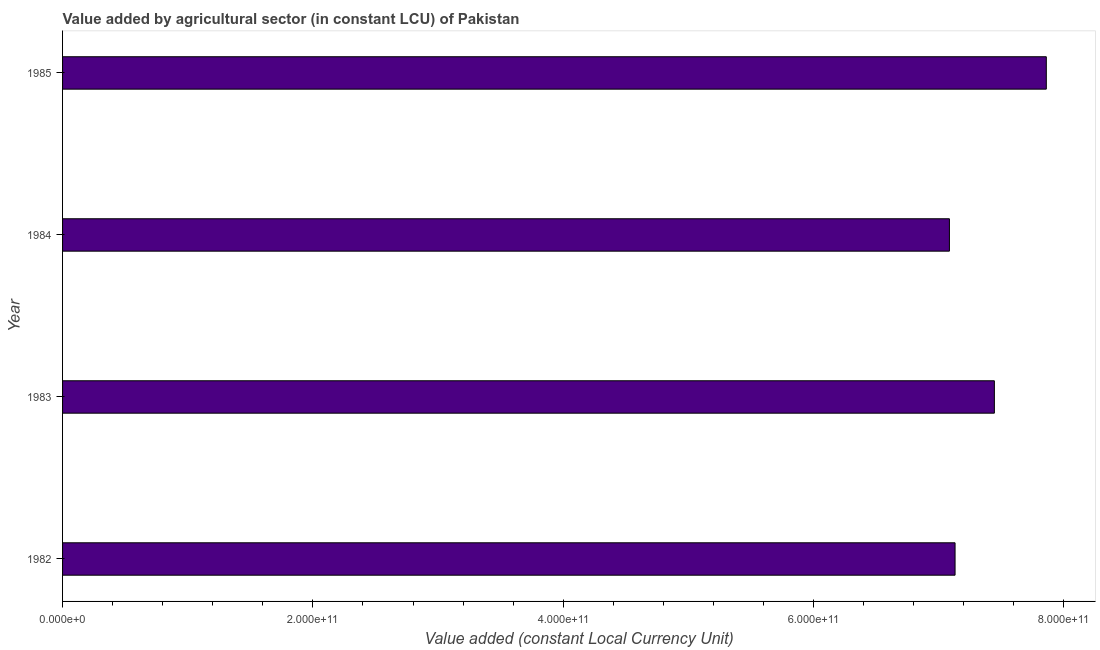Does the graph contain any zero values?
Give a very brief answer. No. What is the title of the graph?
Provide a succinct answer. Value added by agricultural sector (in constant LCU) of Pakistan. What is the label or title of the X-axis?
Your answer should be very brief. Value added (constant Local Currency Unit). What is the label or title of the Y-axis?
Your answer should be compact. Year. What is the value added by agriculture sector in 1985?
Your response must be concise. 7.86e+11. Across all years, what is the maximum value added by agriculture sector?
Provide a succinct answer. 7.86e+11. Across all years, what is the minimum value added by agriculture sector?
Ensure brevity in your answer.  7.09e+11. What is the sum of the value added by agriculture sector?
Provide a succinct answer. 2.95e+12. What is the difference between the value added by agriculture sector in 1983 and 1985?
Offer a terse response. -4.15e+1. What is the average value added by agriculture sector per year?
Ensure brevity in your answer.  7.38e+11. What is the median value added by agriculture sector?
Offer a very short reply. 7.29e+11. In how many years, is the value added by agriculture sector greater than 520000000000 LCU?
Provide a succinct answer. 4. What is the ratio of the value added by agriculture sector in 1983 to that in 1984?
Your answer should be compact. 1.05. Is the difference between the value added by agriculture sector in 1983 and 1985 greater than the difference between any two years?
Your answer should be compact. No. What is the difference between the highest and the second highest value added by agriculture sector?
Your response must be concise. 4.15e+1. Is the sum of the value added by agriculture sector in 1984 and 1985 greater than the maximum value added by agriculture sector across all years?
Provide a short and direct response. Yes. What is the difference between the highest and the lowest value added by agriculture sector?
Your answer should be very brief. 7.74e+1. How many bars are there?
Offer a very short reply. 4. What is the difference between two consecutive major ticks on the X-axis?
Give a very brief answer. 2.00e+11. What is the Value added (constant Local Currency Unit) of 1982?
Your answer should be very brief. 7.13e+11. What is the Value added (constant Local Currency Unit) of 1983?
Your response must be concise. 7.45e+11. What is the Value added (constant Local Currency Unit) of 1984?
Offer a terse response. 7.09e+11. What is the Value added (constant Local Currency Unit) of 1985?
Offer a very short reply. 7.86e+11. What is the difference between the Value added (constant Local Currency Unit) in 1982 and 1983?
Offer a very short reply. -3.14e+1. What is the difference between the Value added (constant Local Currency Unit) in 1982 and 1984?
Your response must be concise. 4.51e+09. What is the difference between the Value added (constant Local Currency Unit) in 1982 and 1985?
Keep it short and to the point. -7.29e+1. What is the difference between the Value added (constant Local Currency Unit) in 1983 and 1984?
Give a very brief answer. 3.59e+1. What is the difference between the Value added (constant Local Currency Unit) in 1983 and 1985?
Keep it short and to the point. -4.15e+1. What is the difference between the Value added (constant Local Currency Unit) in 1984 and 1985?
Provide a succinct answer. -7.74e+1. What is the ratio of the Value added (constant Local Currency Unit) in 1982 to that in 1983?
Provide a succinct answer. 0.96. What is the ratio of the Value added (constant Local Currency Unit) in 1982 to that in 1984?
Provide a short and direct response. 1.01. What is the ratio of the Value added (constant Local Currency Unit) in 1982 to that in 1985?
Offer a terse response. 0.91. What is the ratio of the Value added (constant Local Currency Unit) in 1983 to that in 1984?
Keep it short and to the point. 1.05. What is the ratio of the Value added (constant Local Currency Unit) in 1983 to that in 1985?
Give a very brief answer. 0.95. What is the ratio of the Value added (constant Local Currency Unit) in 1984 to that in 1985?
Ensure brevity in your answer.  0.9. 